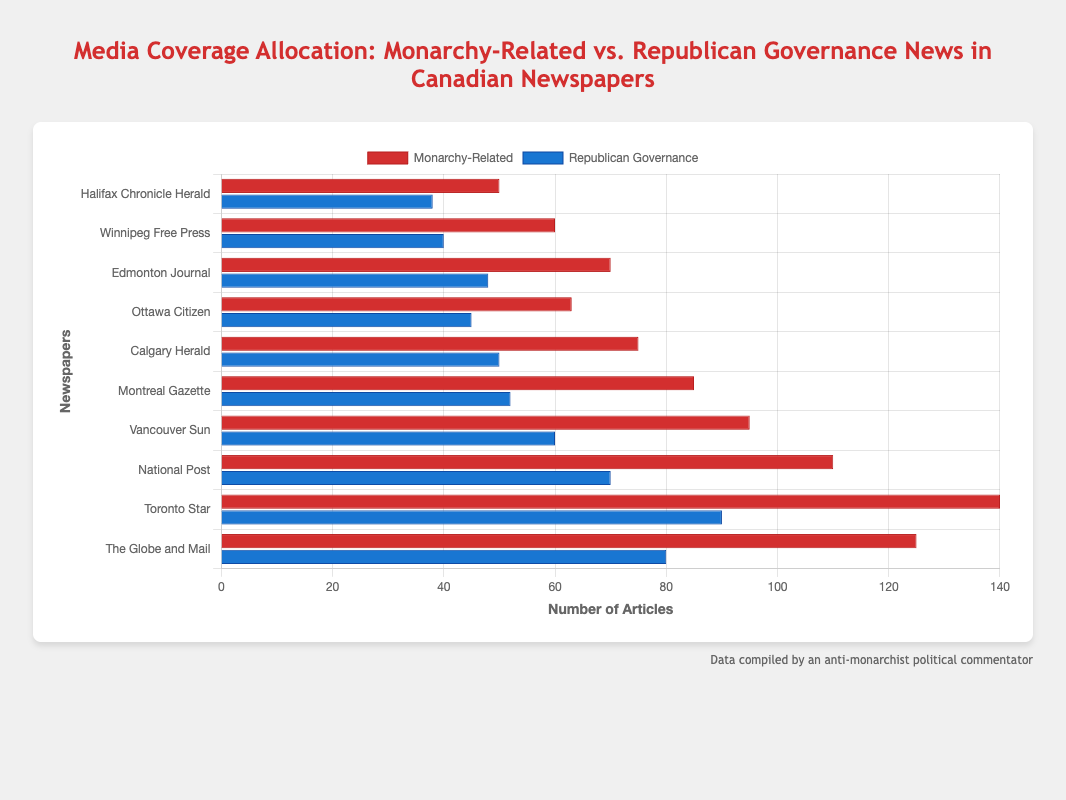What's the total number of Monarchy-Related articles across all newspapers? Sum the Monarchy-Related articles for all newspapers: 125 + 140 + 110 + 95 + 85 + 75 + 63 + 70 + 60 + 50 = 873
Answer: 873 Which newspaper had the highest number of Republican Governance articles? Identify the newspaper with the longest bar for the Republican Governance dataset, which is the "Toronto Star" with 90 articles
Answer: Toronto Star What is the average number of Republican Governance articles across all newspapers? Sum the Republican Governance articles and divide by the number of newspapers: (80 + 90 + 70 + 60 + 52 + 50 + 45 + 48 + 40 + 38) / 10 = 573 / 10 = 57.3
Answer: 57.3 Are there any newspapers where the number of Monarchy-Related articles is less than the number of Republican Governance articles? Compare the values of Monarchy-Related and Republican Governance articles for each newspaper. No newspaper has more Republican Governance articles than Monarchy-Related articles
Answer: No Which newspaper has the biggest difference between Monarchy-Related and Republican Governance articles, and what is that difference? For each newspaper, calculate the difference between Monarchy-Related and Republican Governance articles. The "Toronto Star" has the biggest difference: 140 - 90 = 50
Answer: Toronto Star, 50 Which has more articles on average: Monarchy-Related or Republican Governance news? Calculate the average for both categories: Monarchy-Related: (125 + 140 + 110 + 95 + 85 + 75 + 63 + 70 + 60 + 50) / 10 = 87.3; Republican Governance: (80 + 90 + 70 + 60 + 52 + 50 + 45 + 48 + 40 + 38) / 10 = 57.3. Monarchy-Related articles have a higher average
Answer: Monarchy-Related news Does any newspaper have an equal number of Monarchy-Related and Republican Governance articles? Check all newspapers to find equal values for both categories. None have the same number of articles
Answer: No Which newspaper's bars for Monarchy-Related articles appear approximately twice as long as those for Republican Governance articles? Compare the lengths of the bars. "Ottawa Citizen" has Monarchy-Related articles (63) approximately double the Republican Governance ones (45)
Answer: Ottawa Citizen 